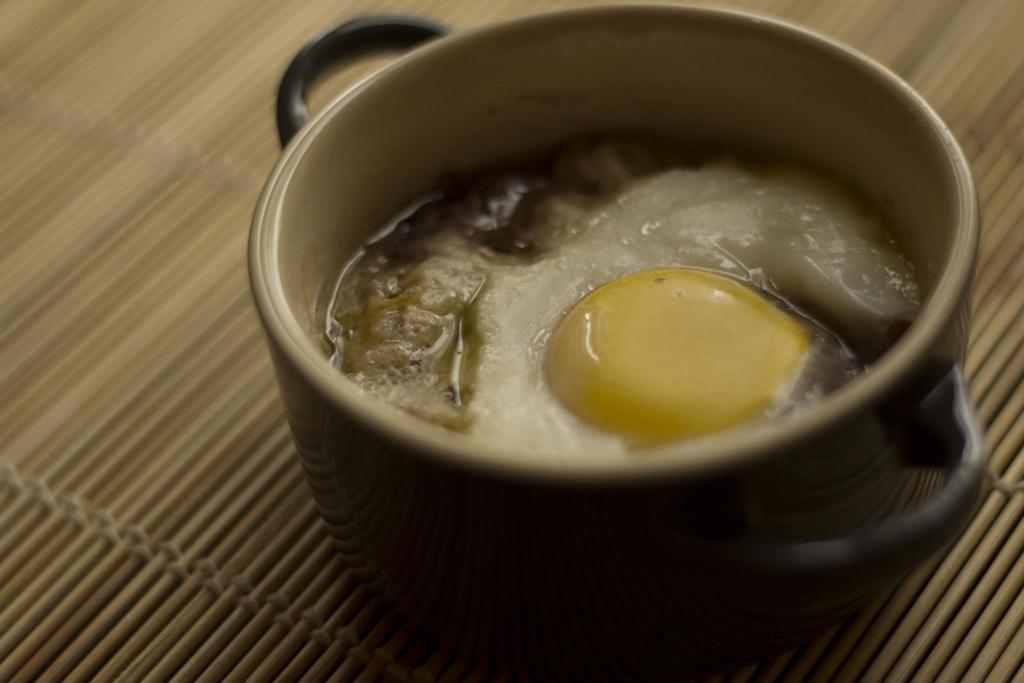What is in the bowl that is visible in the image? There is food in a bowl in the image. What is the bowl placed on in the image? The bowl is on an object in the image. What color is the dress worn by the orange in the picture? There is no orange or dress present in the image. 